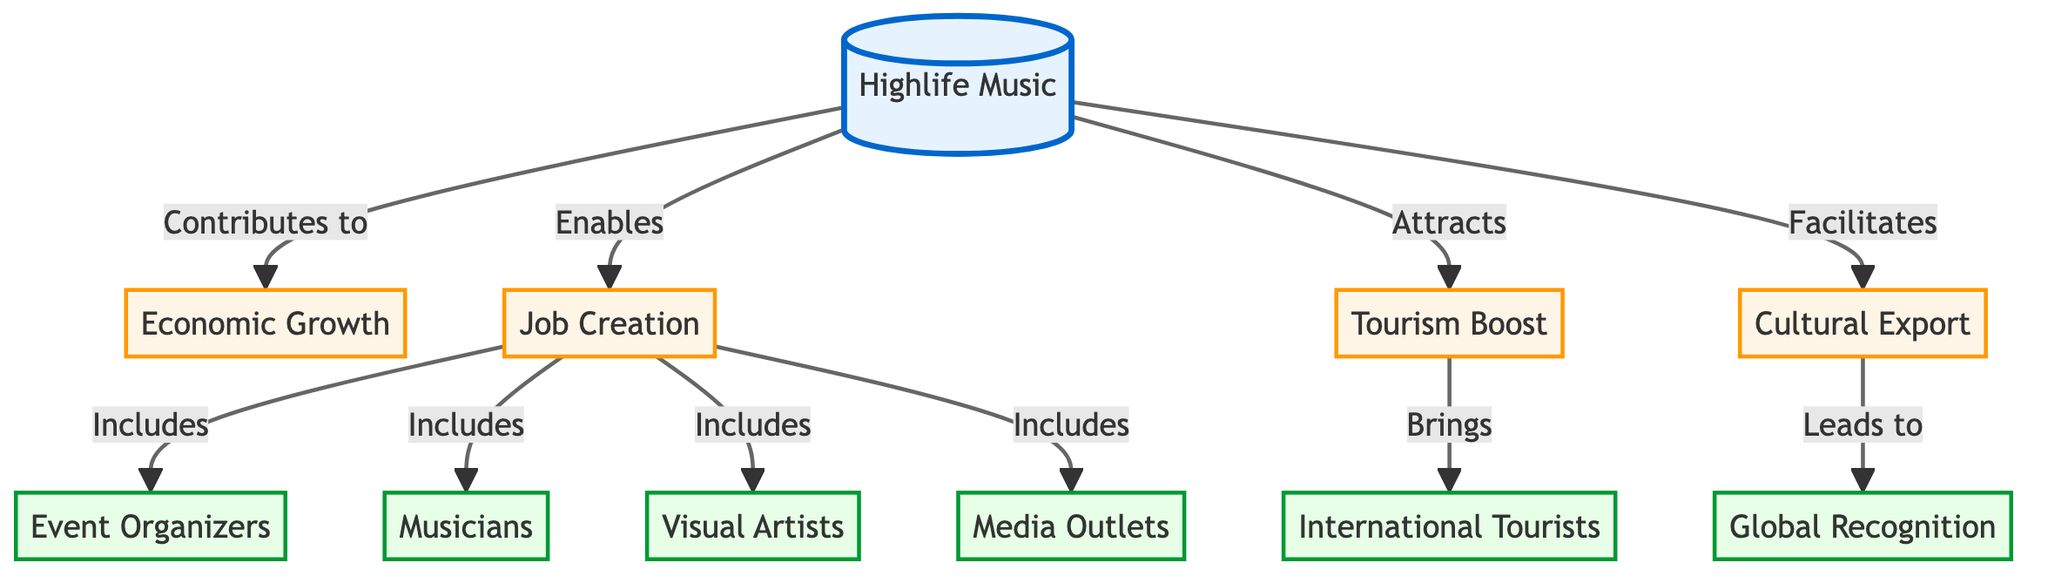What is the main concept depicted in the diagram? The main concept shown in the diagram is "Highlife Music," which is positioned at the top and is the starting point for all subsequent relationships.
Answer: Highlife Music How many primary effects are directly attributed to Highlife Music? The diagram indicates three primary effects linked directly to Highlife Music: Economic Growth, Job Creation, and Tourism Boost. These are represented by three separate nodes directly connected to Highlife Music.
Answer: 3 Which node represents employment opportunities generated by Highlife Music? The node labeled "Job Creation" specifically represents the employment opportunities created as a result of Highlife Music's influence.
Answer: Job Creation What does Job Creation include? Job Creation includes various categories such as Event Organizers, Musicians, Artists, and Media. These are connected nodes under Job Creation, outlining the specific employment areas.
Answer: Event Organizers, Musicians, Artists, Media What is the relationship between Highlife Music and Global Recognition? Highlife Music facilitates Cultural Export, which in turn leads to Global Recognition. This suggests a chain of causality from Highlife Music to Cultural Export and then to Global Recognition.
Answer: Facilitates How does Highlife Music affect Tourism? Highlife Music attracts a boost in tourism, which brings in International Tourists. This shows the direct influence Highlife Music has on enhancing tourist activities in the region.
Answer: Attracts What impact does Cultural Export have according to the diagram? Cultural Export leads to Global Recognition, indicating that the act of exporting cultural elements associated with Highlife Music enhances its international presence and acknowledgment.
Answer: Leads to What group is indirectly affected by Job Creation? Tourists are indirectly affected because they are drawn to the region as a result of the tourism boost, which benefits from various jobs created within the local economy connected to Highlife Music.
Answer: Tourists Which stakeholders are linked to Highlife Music via Economic Growth? The diagram indicates that Economic Growth is a consequence of Highlife Music, suggesting that various stakeholders such as businesses and potentially government entities benefit from this growth.
Answer: Economic Growth 